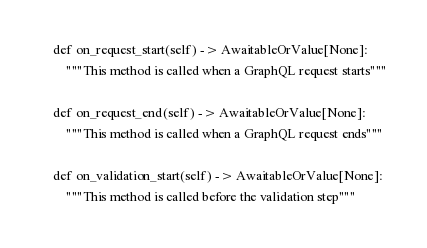<code> <loc_0><loc_0><loc_500><loc_500><_Python_>    def on_request_start(self) -> AwaitableOrValue[None]:
        """This method is called when a GraphQL request starts"""

    def on_request_end(self) -> AwaitableOrValue[None]:
        """This method is called when a GraphQL request ends"""

    def on_validation_start(self) -> AwaitableOrValue[None]:
        """This method is called before the validation step"""
</code> 